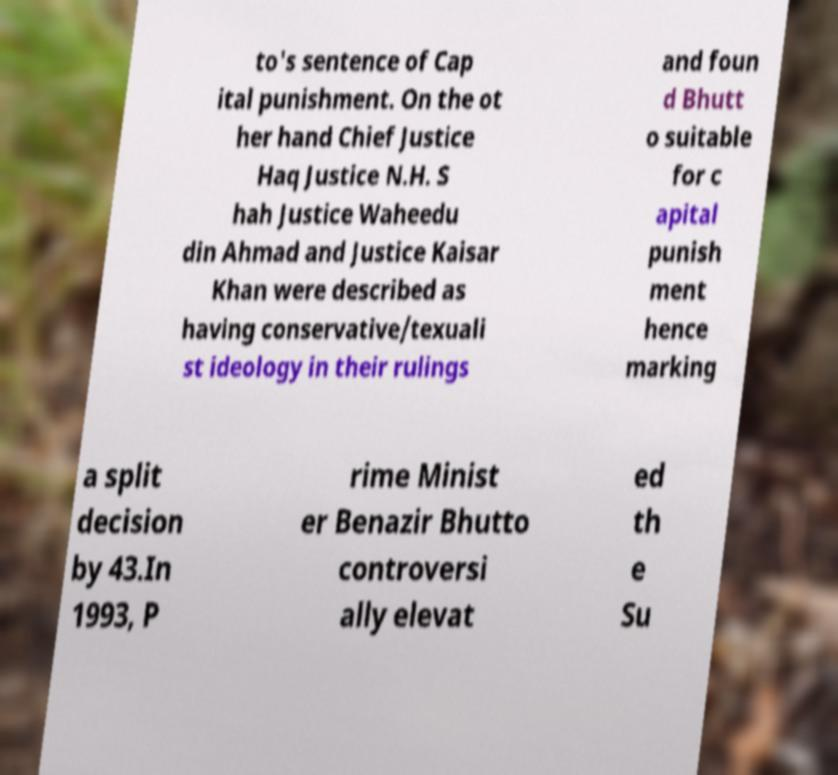Can you read and provide the text displayed in the image?This photo seems to have some interesting text. Can you extract and type it out for me? to's sentence of Cap ital punishment. On the ot her hand Chief Justice Haq Justice N.H. S hah Justice Waheedu din Ahmad and Justice Kaisar Khan were described as having conservative/texuali st ideology in their rulings and foun d Bhutt o suitable for c apital punish ment hence marking a split decision by 43.In 1993, P rime Minist er Benazir Bhutto controversi ally elevat ed th e Su 